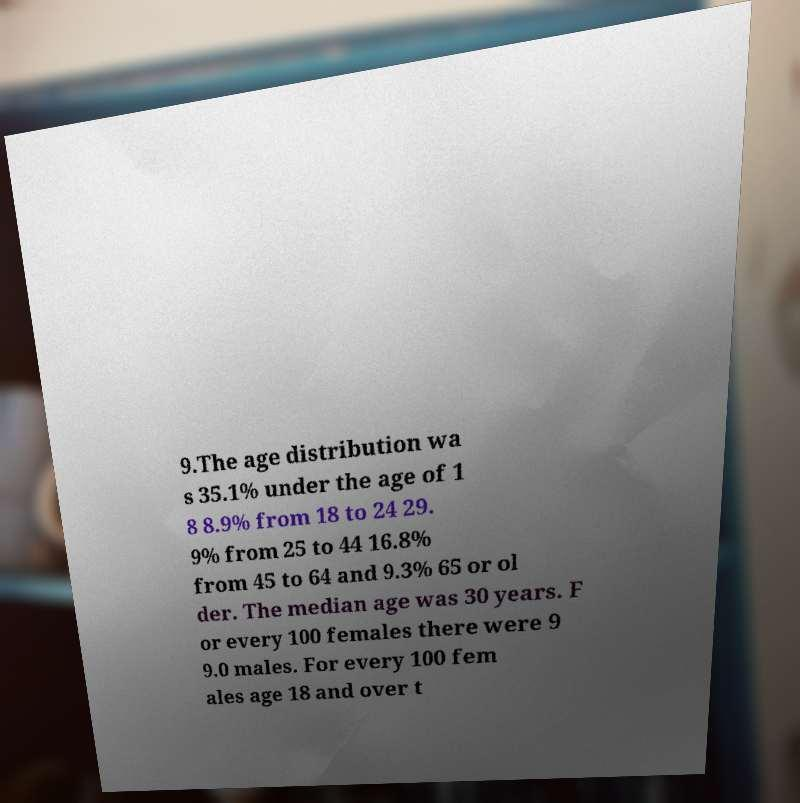Please identify and transcribe the text found in this image. 9.The age distribution wa s 35.1% under the age of 1 8 8.9% from 18 to 24 29. 9% from 25 to 44 16.8% from 45 to 64 and 9.3% 65 or ol der. The median age was 30 years. F or every 100 females there were 9 9.0 males. For every 100 fem ales age 18 and over t 